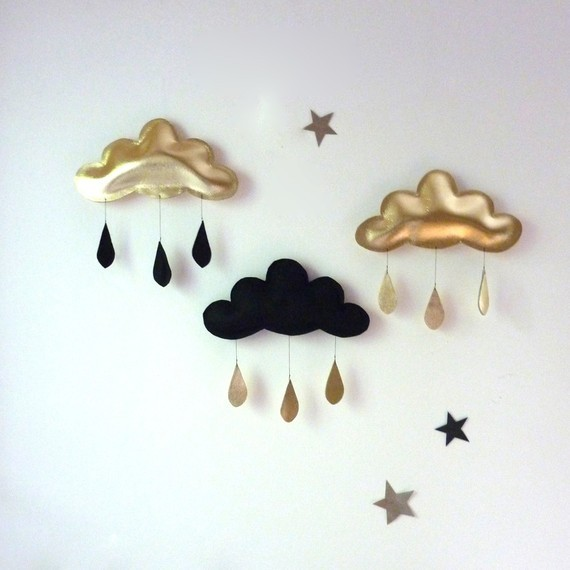Could the clouds with contrasting raindrops represent any specific philosophical or cultural concepts? Yes, the clouds with contrasting colors indeed echo philosophical and cultural motifs, particularly the dualistic principles found across various cultures. For instance, they might symbolize the Chinese philosophy of Yin and Yang, where opposite forces are interconnected and co-dependent. Additionally, they can be seen as reflecting the Western concept of the 'Golden Mean', the desirable middle between two extremes, one of excess and the other of deficiency. The clouds could also be tapping into themes of alchemy, where the transformation of base substances into noble ones symbolizes personal growth and enlightenment. 